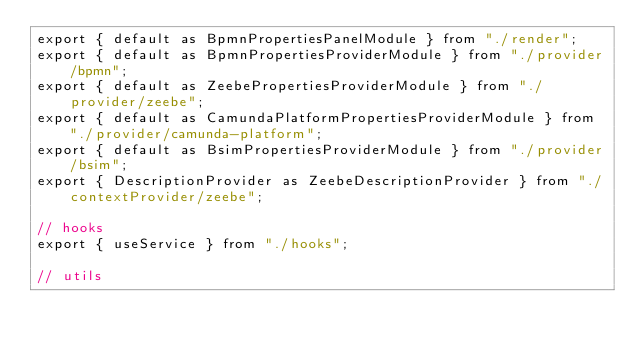Convert code to text. <code><loc_0><loc_0><loc_500><loc_500><_JavaScript_>export { default as BpmnPropertiesPanelModule } from "./render";
export { default as BpmnPropertiesProviderModule } from "./provider/bpmn";
export { default as ZeebePropertiesProviderModule } from "./provider/zeebe";
export { default as CamundaPlatformPropertiesProviderModule } from "./provider/camunda-platform";
export { default as BsimPropertiesProviderModule } from "./provider/bsim";
export { DescriptionProvider as ZeebeDescriptionProvider } from "./contextProvider/zeebe";

// hooks
export { useService } from "./hooks";

// utils
</code> 